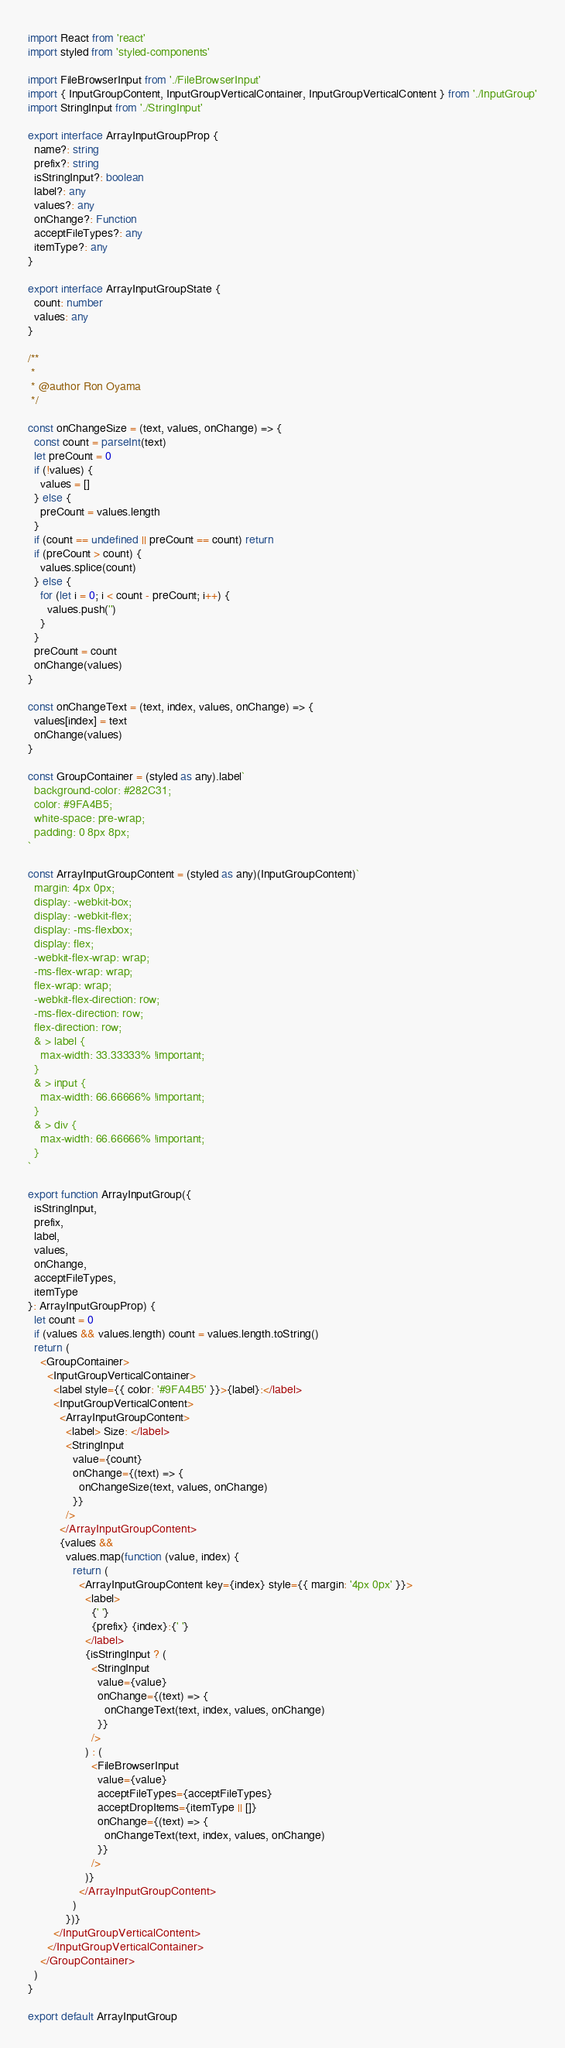Convert code to text. <code><loc_0><loc_0><loc_500><loc_500><_TypeScript_>import React from 'react'
import styled from 'styled-components'

import FileBrowserInput from './FileBrowserInput'
import { InputGroupContent, InputGroupVerticalContainer, InputGroupVerticalContent } from './InputGroup'
import StringInput from './StringInput'

export interface ArrayInputGroupProp {
  name?: string
  prefix?: string
  isStringInput?: boolean
  label?: any
  values?: any
  onChange?: Function
  acceptFileTypes?: any
  itemType?: any
}

export interface ArrayInputGroupState {
  count: number
  values: any
}

/**
 *
 * @author Ron Oyama
 */

const onChangeSize = (text, values, onChange) => {
  const count = parseInt(text)
  let preCount = 0
  if (!values) {
    values = []
  } else {
    preCount = values.length
  }
  if (count == undefined || preCount == count) return
  if (preCount > count) {
    values.splice(count)
  } else {
    for (let i = 0; i < count - preCount; i++) {
      values.push('')
    }
  }
  preCount = count
  onChange(values)
}

const onChangeText = (text, index, values, onChange) => {
  values[index] = text
  onChange(values)
}

const GroupContainer = (styled as any).label`
  background-color: #282C31;
  color: #9FA4B5;
  white-space: pre-wrap;
  padding: 0 8px 8px;
`

const ArrayInputGroupContent = (styled as any)(InputGroupContent)`
  margin: 4px 0px;
  display: -webkit-box;
  display: -webkit-flex;
  display: -ms-flexbox;
  display: flex;
  -webkit-flex-wrap: wrap;
  -ms-flex-wrap: wrap;
  flex-wrap: wrap;
  -webkit-flex-direction: row;
  -ms-flex-direction: row;
  flex-direction: row;
  & > label {
    max-width: 33.33333% !important;
  }
  & > input {
    max-width: 66.66666% !important;
  }
  & > div {
    max-width: 66.66666% !important;
  }
`

export function ArrayInputGroup({
  isStringInput,
  prefix,
  label,
  values,
  onChange,
  acceptFileTypes,
  itemType
}: ArrayInputGroupProp) {
  let count = 0
  if (values && values.length) count = values.length.toString()
  return (
    <GroupContainer>
      <InputGroupVerticalContainer>
        <label style={{ color: '#9FA4B5' }}>{label}:</label>
        <InputGroupVerticalContent>
          <ArrayInputGroupContent>
            <label> Size: </label>
            <StringInput
              value={count}
              onChange={(text) => {
                onChangeSize(text, values, onChange)
              }}
            />
          </ArrayInputGroupContent>
          {values &&
            values.map(function (value, index) {
              return (
                <ArrayInputGroupContent key={index} style={{ margin: '4px 0px' }}>
                  <label>
                    {' '}
                    {prefix} {index}:{' '}
                  </label>
                  {isStringInput ? (
                    <StringInput
                      value={value}
                      onChange={(text) => {
                        onChangeText(text, index, values, onChange)
                      }}
                    />
                  ) : (
                    <FileBrowserInput
                      value={value}
                      acceptFileTypes={acceptFileTypes}
                      acceptDropItems={itemType || []}
                      onChange={(text) => {
                        onChangeText(text, index, values, onChange)
                      }}
                    />
                  )}
                </ArrayInputGroupContent>
              )
            })}
        </InputGroupVerticalContent>
      </InputGroupVerticalContainer>
    </GroupContainer>
  )
}

export default ArrayInputGroup
</code> 